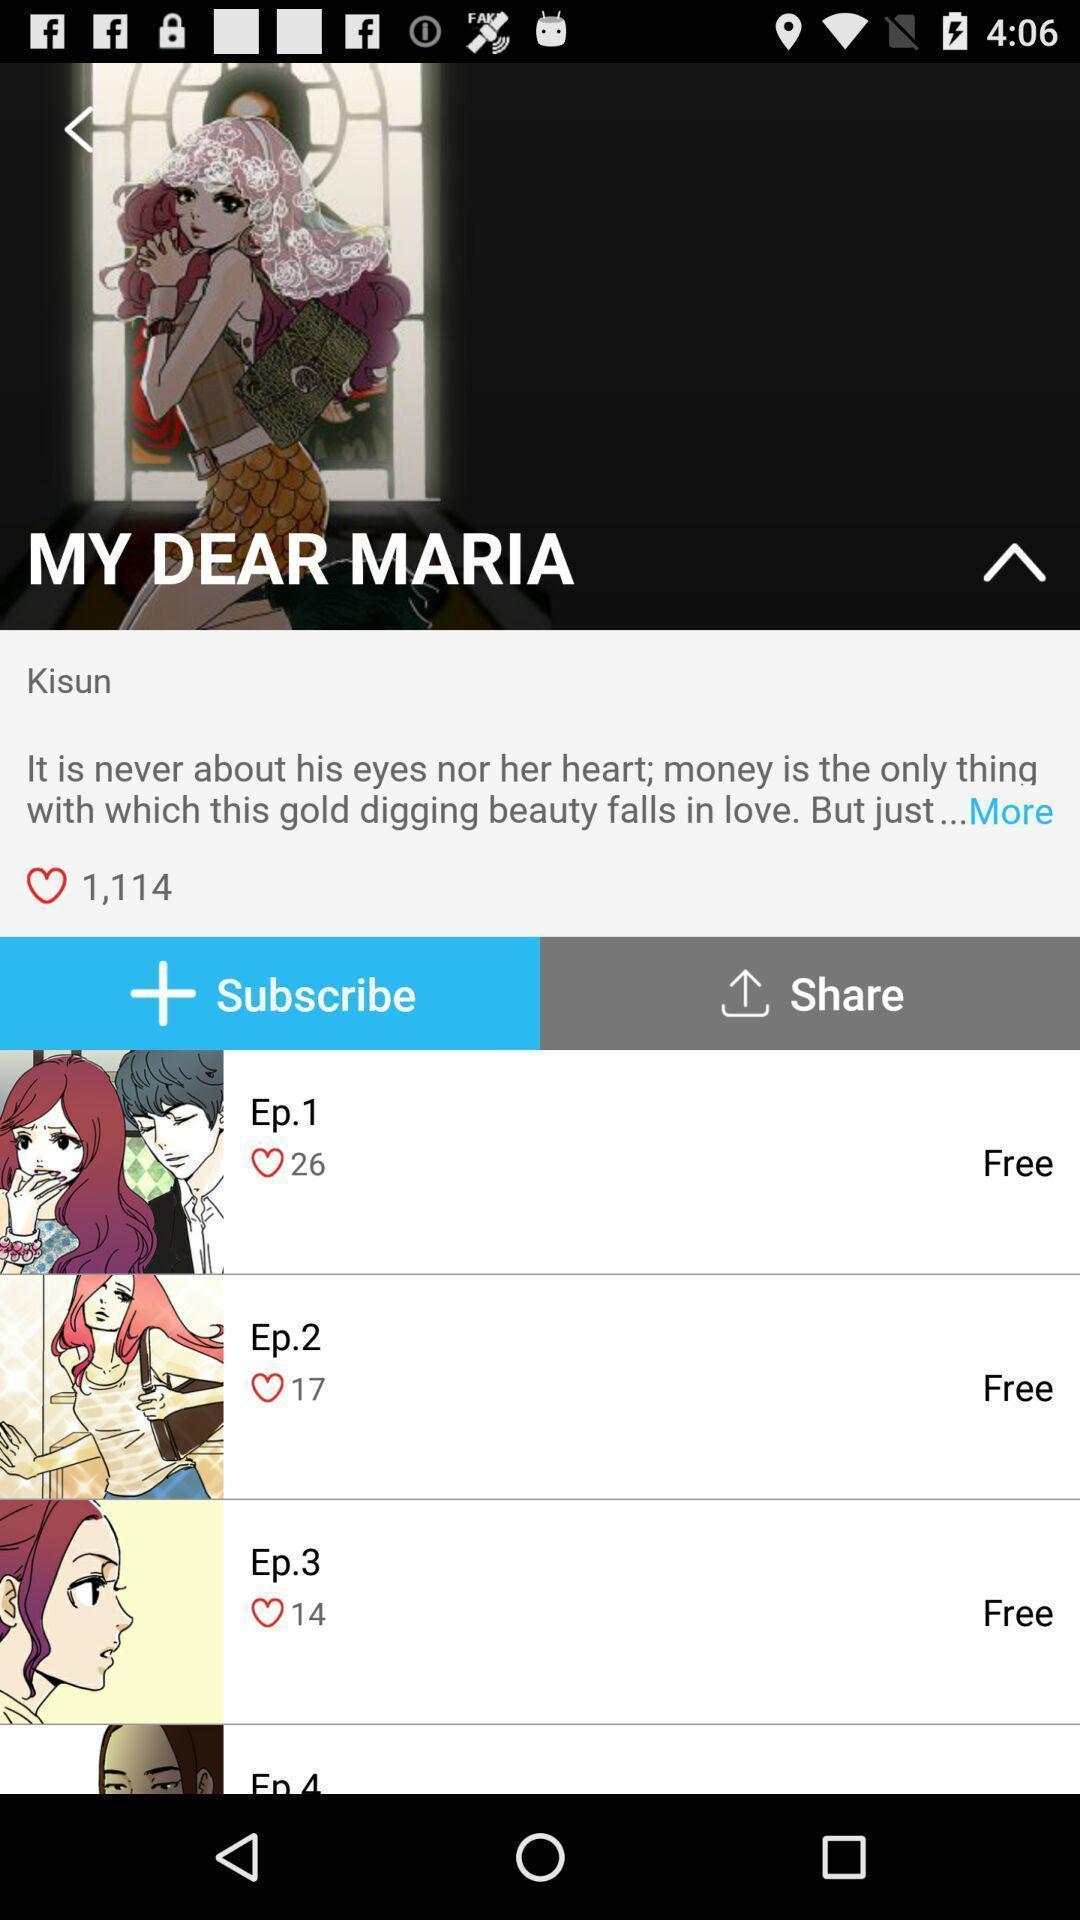Summarize the main components in this picture. Page showing information about application. 